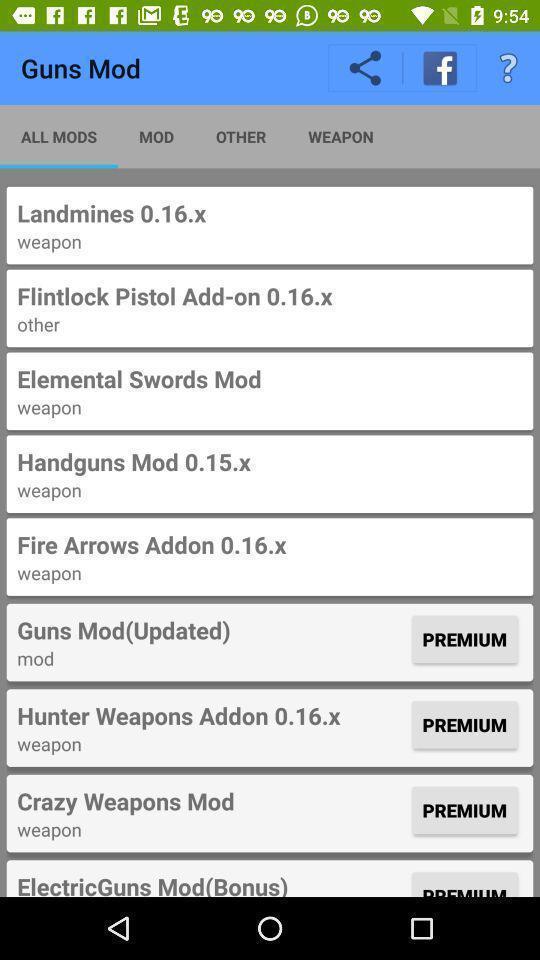Provide a textual representation of this image. Page showing list of various options gun mods. 